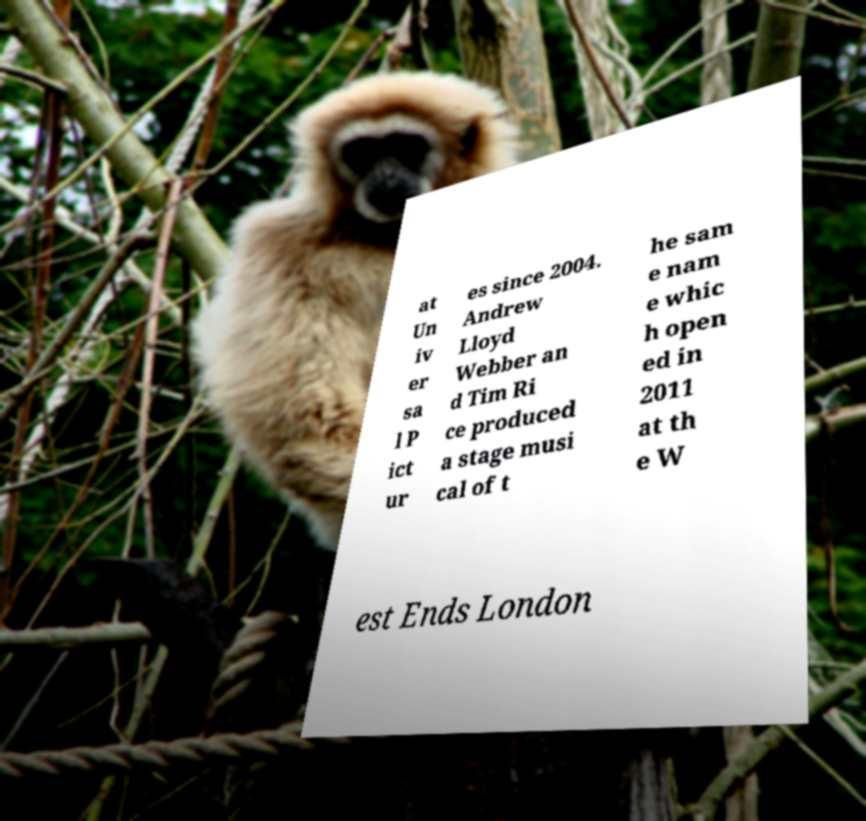What messages or text are displayed in this image? I need them in a readable, typed format. at Un iv er sa l P ict ur es since 2004. Andrew Lloyd Webber an d Tim Ri ce produced a stage musi cal of t he sam e nam e whic h open ed in 2011 at th e W est Ends London 